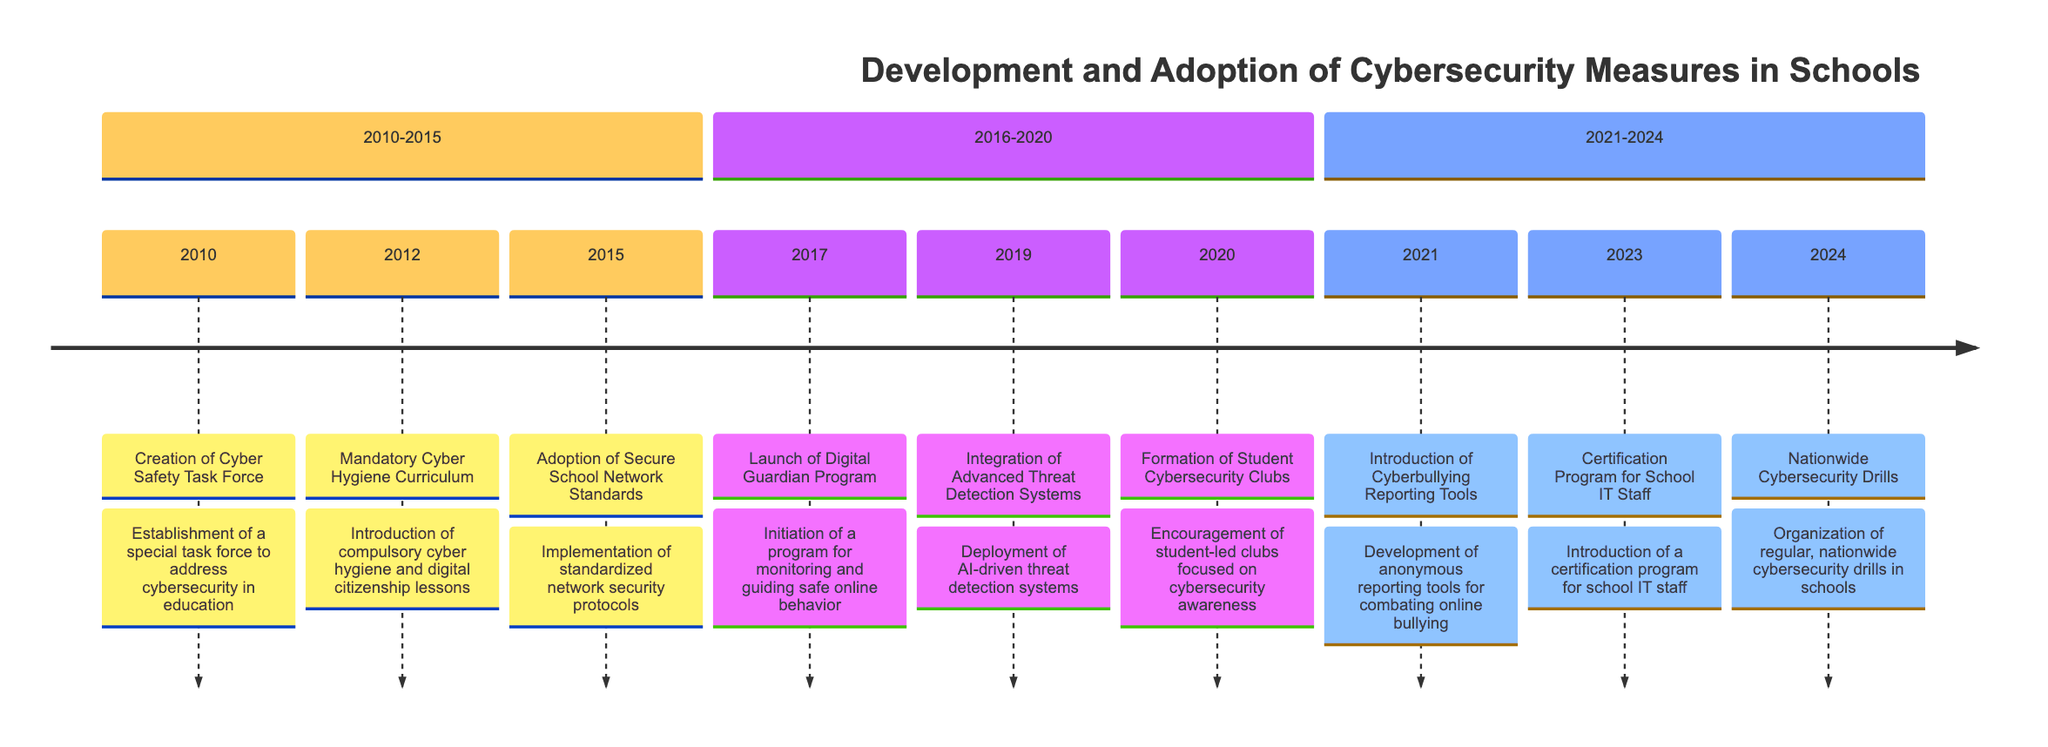What year was the Cyber Safety Task Force created? The diagram indicates that the Cyber Safety Task Force was created in 2010, as stated in the first event listed in the timeline.
Answer: 2010 What significant cybersecurity event took place in 2015? The event listed for 2015 is the "Adoption of Secure School Network Standards," which indicates that standardized network security protocols were implemented that year.
Answer: Adoption of Secure School Network Standards What is the focus of the Mandatory Cyber Hygiene Curriculum introduced in 2012? The description accompanying the event in 2012 outlines that the focus is on "safe online practices and recognizing cyber threats," which is part of the curriculum's objective.
Answer: Safe online practices and recognizing cyber threats Which program was launched in 2017? The timeline specifically states that the "Digital Guardian Program" was launched in 2017, meaning it is the key event for that year.
Answer: Digital Guardian Program How many cybersecurity measures were introduced between 2010 and 2020? By counting the individual events listed in the timeline from 2010 to 2020, there are five distinct measures introduced: Cyber Safety Task Force, Mandatory Cyber Hygiene Curriculum, Secure School Network Standards, Digital Guardian Program, and Advanced Threat Detection Systems.
Answer: Five What event is scheduled for 2024? The timeline indicates that the event for 2024 is the "Nationwide Cybersecurity Drills," which is when regular, nationwide drills in schools are organized.
Answer: Nationwide Cybersecurity Drills Which year saw the introduction of tools for reporting cyberbullying? According to the timeline, the introduction of Cyberbullying Reporting Tools occurred in 2021, marking that year as significant for this initiative.
Answer: 2021 What significant trend can be observed from the timeline between 2010 to 2024? Analyzing the events listed from 2010 to 2024 reveals a consistent trend of increasing initiatives focused on enhancing cybersecurity measures in schools, indicating a long-term commitment to improving digital safety.
Answer: Increasing initiatives in cybersecurity How many sections are there in the timeline? The diagram divides the timeline into three sections: 2010-2015, 2016-2020, and 2021-2024, totaling three distinct sections.
Answer: Three 